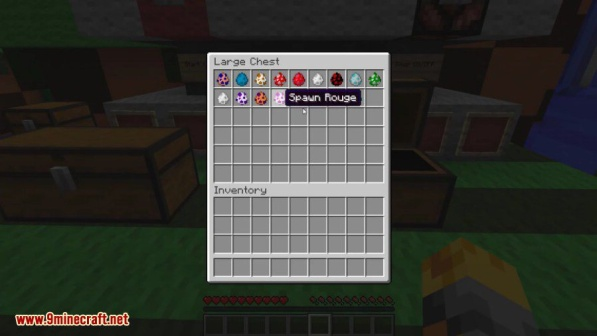If you were to suggest a creative project for the player to undertake with their current resources, what would it be? With the current resources available in the chest, a fascinating project for the player could be to create a magical zoo and botanical garden. Using the spawn eggs, the player can generate various mobs and creatures, designing distinct habitats for each one. They could build enclosures and themed areas, ensuring each creature has an environment that reflects its natural habitat.

The enchanted books can be used to create specialized equipment, such as tools for creating intricate landscape designs and weapons for protecting the zoo from potential threats. The diamonds could be utilized to craft durable and powerful gear, ensuring the player's safety as they manage and maintain the zoo.

For the botanical garden aspect, the player can use flowers and other plant items to create lush, vibrant gardens. Incorporating water features, different types of foliage, and perhaps even redstone-powered mechanical elements can add an interactive and visually appealing aspect to the garden. The potion from the chest can be used to create a mystical section of the garden, where visitors can experience enchanted effects.

Overall, this project would not only make use of the player's diverse inventory but also provide a creative and enjoyable challenge, transforming their base into a haven of nature and magic within the Minecraft world. 